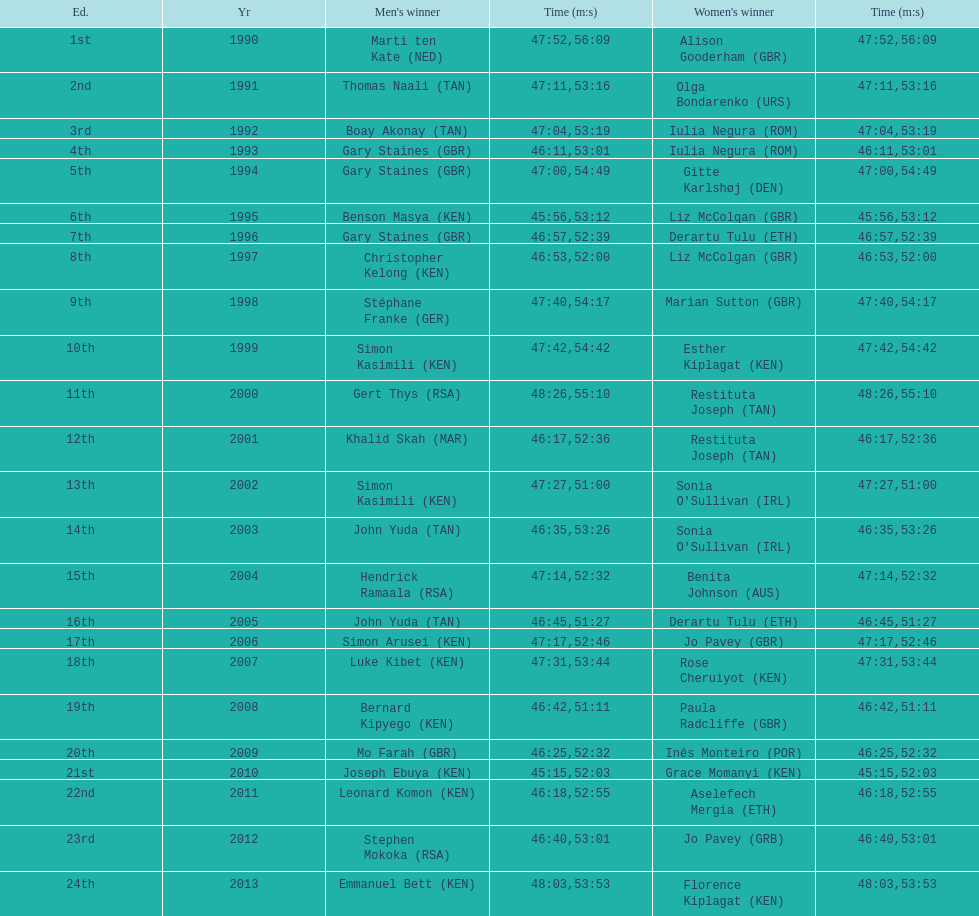What is the difference in finishing times for the men's and women's bupa great south run finish for 2013? 5:50. 